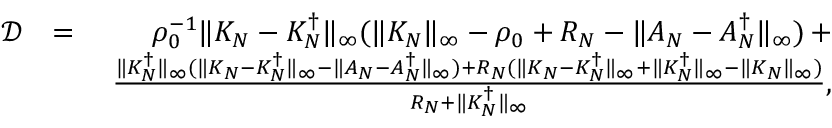<formula> <loc_0><loc_0><loc_500><loc_500>\begin{array} { r l r } { \mathcal { D } } & { = } & { \rho _ { 0 } ^ { - 1 } \| K _ { N } - K _ { N } ^ { \dag } \| _ { \infty } ( \| K _ { N } \| _ { \infty } - \rho _ { 0 } + R _ { N } - \| A _ { N } - A _ { N } ^ { \dag } \| _ { \infty } ) \, + } \\ & { \, \frac { \| K _ { N } ^ { \dag } \| _ { \infty } ( \| K _ { N } - K _ { N } ^ { \dag } \| _ { \infty } - \| A _ { N } - A _ { N } ^ { \dag } \| _ { \infty } ) + R _ { N } ( \| K _ { N } - K _ { N } ^ { \dag } \| _ { \infty } + \| K _ { N } ^ { \dag } \| _ { \infty } - \| K _ { N } \| _ { \infty } ) } { R _ { N } + \| K _ { N } ^ { \dag } \| _ { \infty } } , } \end{array}</formula> 